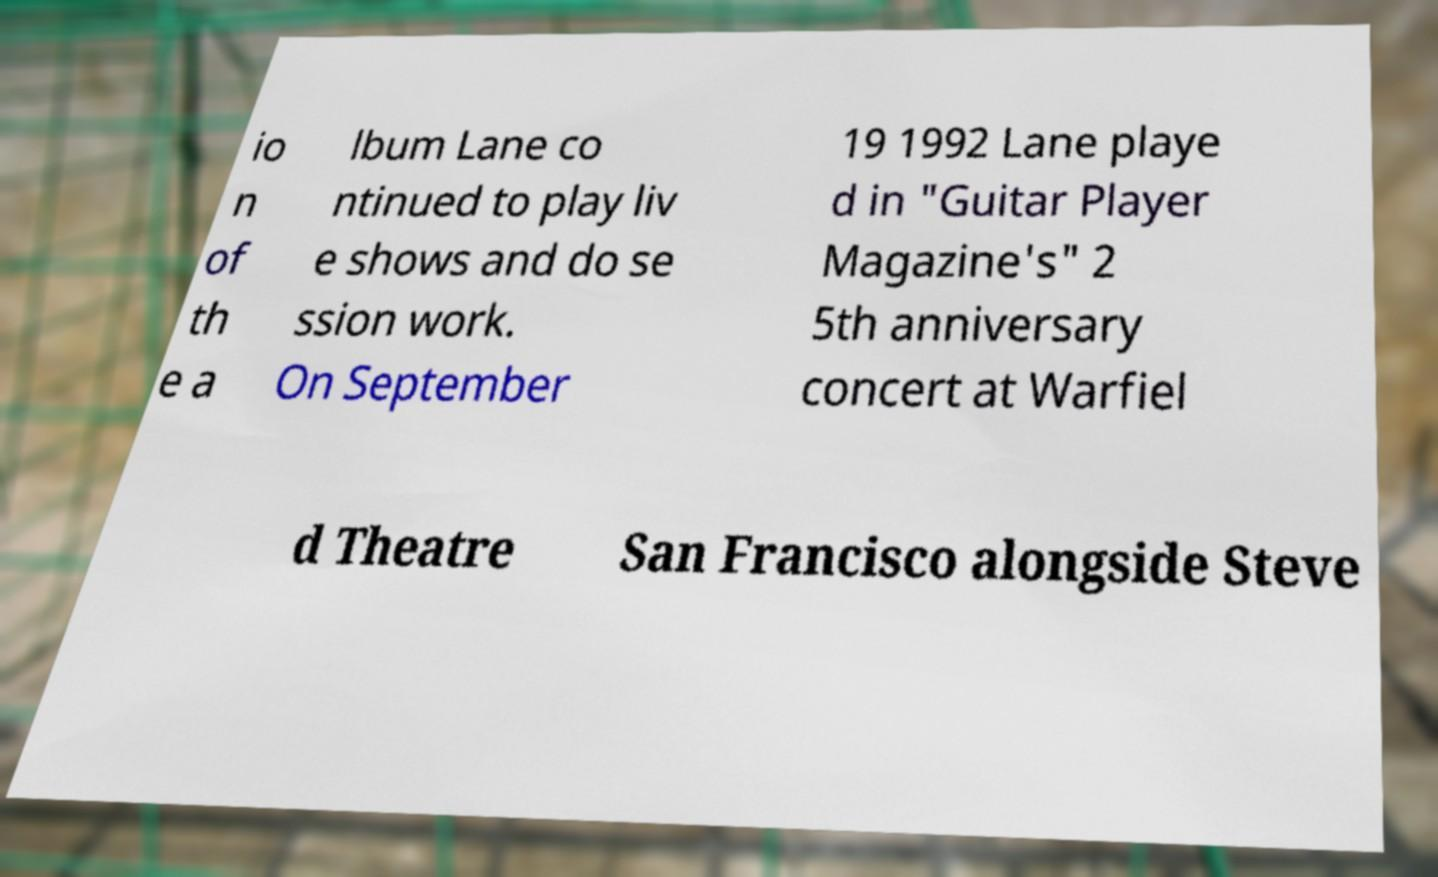Could you extract and type out the text from this image? io n of th e a lbum Lane co ntinued to play liv e shows and do se ssion work. On September 19 1992 Lane playe d in "Guitar Player Magazine's" 2 5th anniversary concert at Warfiel d Theatre San Francisco alongside Steve 